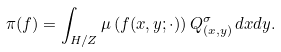Convert formula to latex. <formula><loc_0><loc_0><loc_500><loc_500>\pi ( f ) = \int _ { H / Z } \mu \left ( f ( x , y ; \cdot ) \right ) Q ^ { \sigma } _ { ( x , y ) } \, d x d y .</formula> 